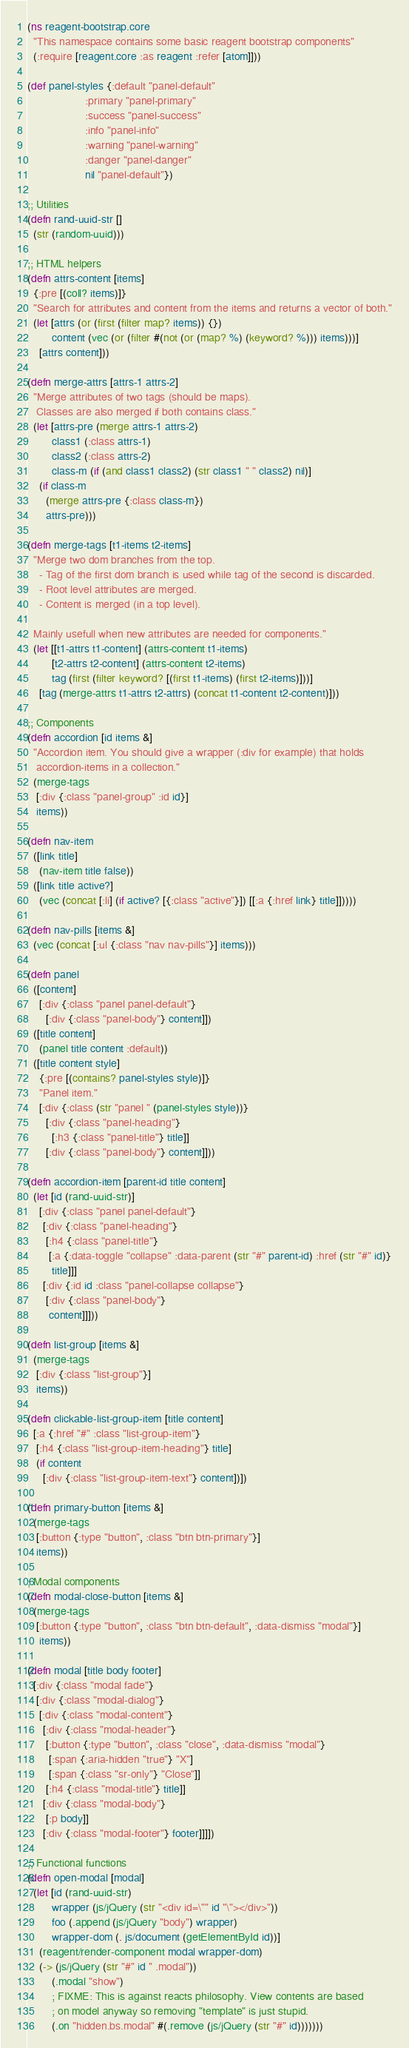Convert code to text. <code><loc_0><loc_0><loc_500><loc_500><_Clojure_>(ns reagent-bootstrap.core
  "This namespace contains some basic reagent bootstrap components"
  (:require [reagent.core :as reagent :refer [atom]]))

(def panel-styles {:default "panel-default"
                   :primary "panel-primary"
                   :success "panel-success"
                   :info "panel-info"
                   :warning "panel-warning"
                   :danger "panel-danger"
                   nil "panel-default"})

;; Utilities
(defn rand-uuid-str []
  (str (random-uuid)))

;; HTML helpers
(defn attrs-content [items]
  {:pre [(coll? items)]}
  "Search for attributes and content from the items and returns a vector of both."
  (let [attrs (or (first (filter map? items)) {})
        content (vec (or (filter #(not (or (map? %) (keyword? %))) items)))]
    [attrs content]))

(defn merge-attrs [attrs-1 attrs-2]
  "Merge attributes of two tags (should be maps).
   Classes are also merged if both contains class."
  (let [attrs-pre (merge attrs-1 attrs-2)
        class1 (:class attrs-1)
        class2 (:class attrs-2)
        class-m (if (and class1 class2) (str class1 " " class2) nil)]
    (if class-m
      (merge attrs-pre {:class class-m})
      attrs-pre)))

(defn merge-tags [t1-items t2-items]
  "Merge two dom branches from the top.
    - Tag of the first dom branch is used while tag of the second is discarded.
    - Root level attributes are merged.
    - Content is merged (in a top level).

  Mainly usefull when new attributes are needed for components."
  (let [[t1-attrs t1-content] (attrs-content t1-items)
        [t2-attrs t2-content] (attrs-content t2-items)
        tag (first (filter keyword? [(first t1-items) (first t2-items)]))]
    [tag (merge-attrs t1-attrs t2-attrs) (concat t1-content t2-content)]))

;; Components
(defn accordion [id items &]
  "Accordion item. You should give a wrapper (:div for example) that holds
   accordion-items in a collection."
  (merge-tags
   [:div {:class "panel-group" :id id}]
   items))

(defn nav-item
  ([link title]
    (nav-item title false))
  ([link title active?]
    (vec (concat [:li] (if active? [{:class "active"}]) [[:a {:href link} title]]))))

(defn nav-pills [items &]
  (vec (concat [:ul {:class "nav nav-pills"}] items)))

(defn panel
  ([content]
    [:div {:class "panel panel-default"}
      [:div {:class "panel-body"} content]])
  ([title content]
    (panel title content :default))
  ([title content style]
    {:pre [(contains? panel-styles style)]}
    "Panel item."
    [:div {:class (str "panel " (panel-styles style))}
      [:div {:class "panel-heading"}
        [:h3 {:class "panel-title"} title]]
      [:div {:class "panel-body"} content]]))

(defn accordion-item [parent-id title content]
  (let [id (rand-uuid-str)]
    [:div {:class "panel panel-default"}
     [:div {:class "panel-heading"}
      [:h4 {:class "panel-title"}
       [:a {:data-toggle "collapse" :data-parent (str "#" parent-id) :href (str "#" id)}
        title]]]
     [:div {:id id :class "panel-collapse collapse"}
      [:div {:class "panel-body"}
       content]]]))

(defn list-group [items &]
  (merge-tags
   [:div {:class "list-group"}]
   items))

(defn clickable-list-group-item [title content]
  [:a {:href "#" :class "list-group-item"}
   [:h4 {:class "list-group-item-heading"} title]
   (if content
     [:div {:class "list-group-item-text"} content])])

(defn primary-button [items &]
  (merge-tags
   [:button {:type "button", :class "btn btn-primary"}]
   items))

; Modal components
(defn modal-close-button [items &]
  (merge-tags
   [:button {:type "button", :class "btn btn-default", :data-dismiss "modal"}]
    items))

(defn modal [title body footer]
  [:div {:class "modal fade"}
   [:div {:class "modal-dialog"}
    [:div {:class "modal-content"}
     [:div {:class "modal-header"}
      [:button {:type "button", :class "close", :data-dismiss "modal"}
       [:span {:aria-hidden "true"} "X"]
       [:span {:class "sr-only"} "Close"]]
      [:h4 {:class "modal-title"} title]]
     [:div {:class "modal-body"}
      [:p body]]
     [:div {:class "modal-footer"} footer]]]])

;; Functional functions
(defn open-modal [modal]
  (let [id (rand-uuid-str)
        wrapper (js/jQuery (str "<div id=\"" id "\"></div>"))
        foo (.append (js/jQuery "body") wrapper)
        wrapper-dom (. js/document (getElementById id))]
    (reagent/render-component modal wrapper-dom)
    (-> (js/jQuery (str "#" id " .modal"))
        (.modal "show")
        ; FIXME: This is against reacts philosophy. View contents are based
        ; on model anyway so removing "template" is just stupid.
        (.on "hidden.bs.modal" #(.remove (js/jQuery (str "#" id)))))))
</code> 